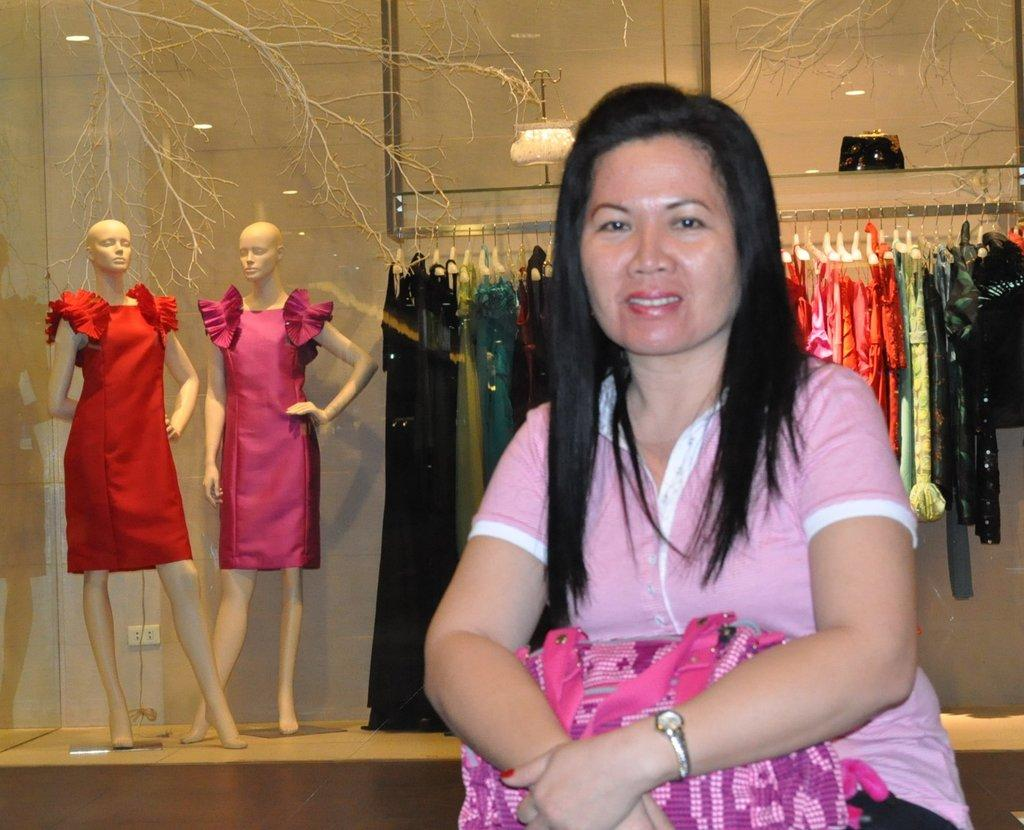What is the woman in the image doing? The woman is sitting in the image. What is the woman holding in the image? The woman is holding a bag. What can be seen in the background of the image? There are clothes hanged in the background of the image. How many mannequins are present in the image? There are two mannequins in the image. What type of corn is being taught to the woman in the image? There is no corn or teaching activity present in the image. 